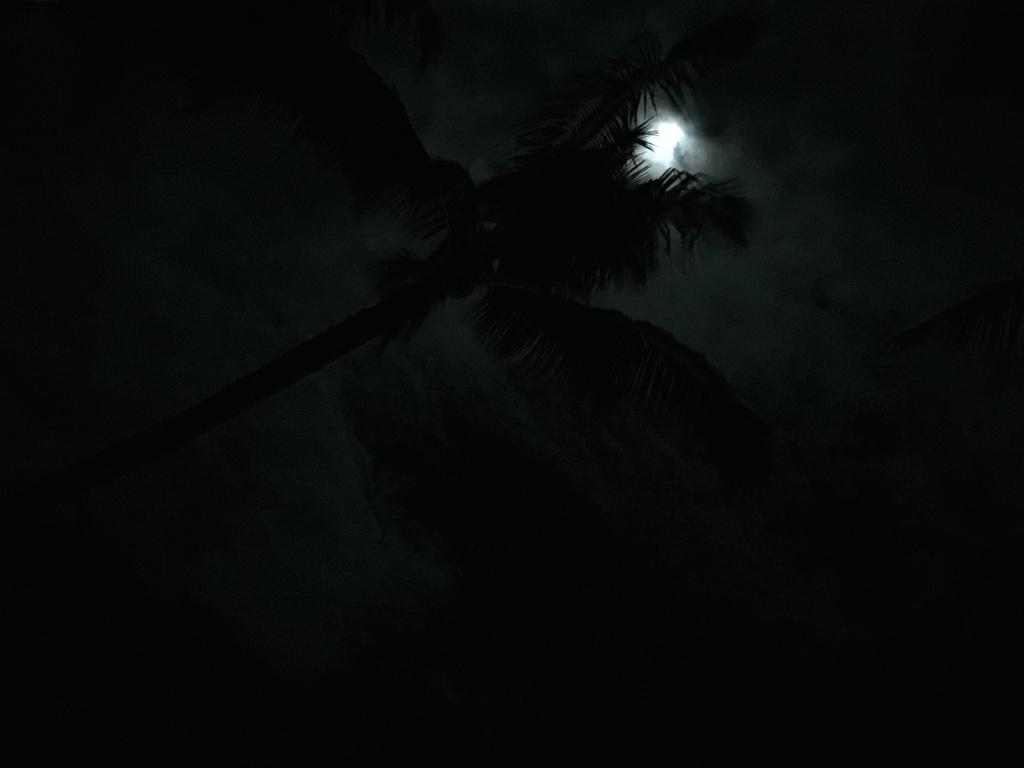What is located on the left side of the image? There is a tree on the left side of the image. What celestial body can be seen in the sky? The moon is visible in the sky. How would you describe the overall lighting in the image? The background of the image has a dark view. What type of flame can be seen coming from the tree in the image? There is no flame present in the image; it features a tree and the moon in a dark background. How many pickles are hanging from the branches of the tree in the image? There are no pickles present in the image; it only features a tree and the moon in a dark background. 